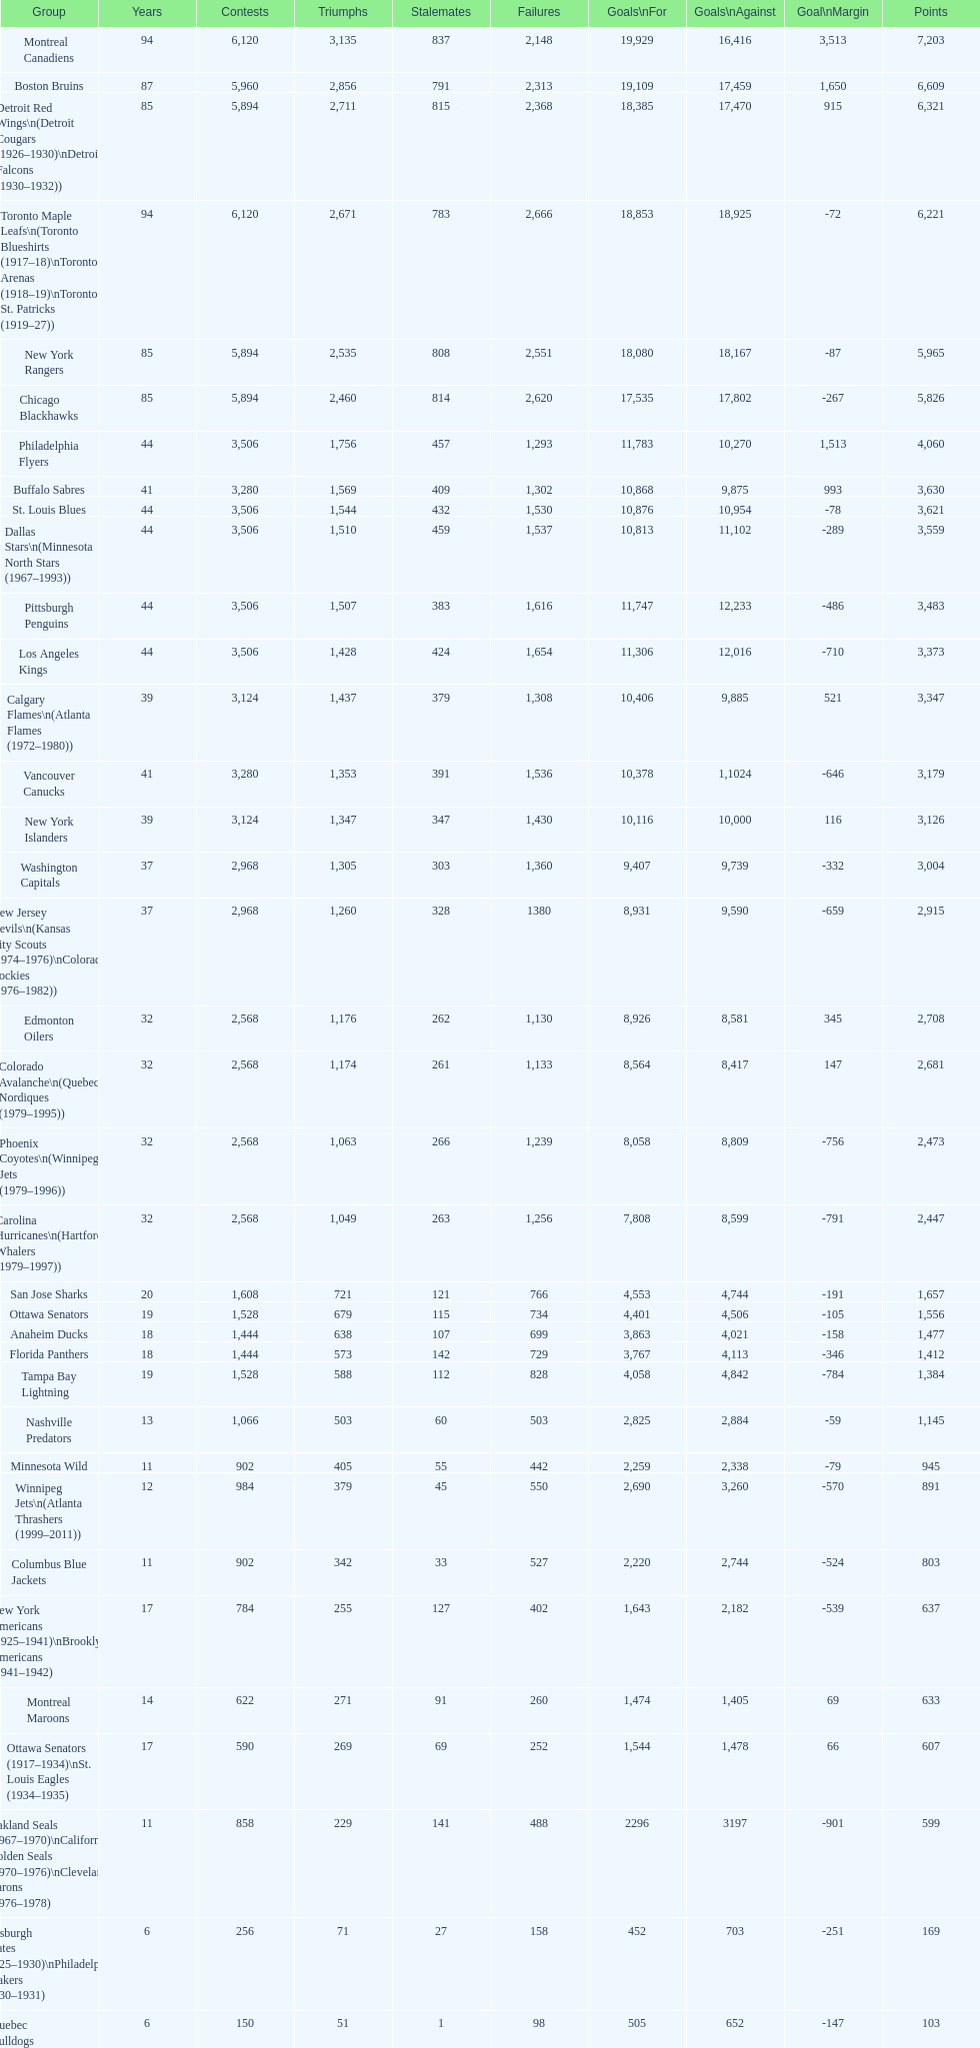How many teams have won more than 1,500 games? 11. 